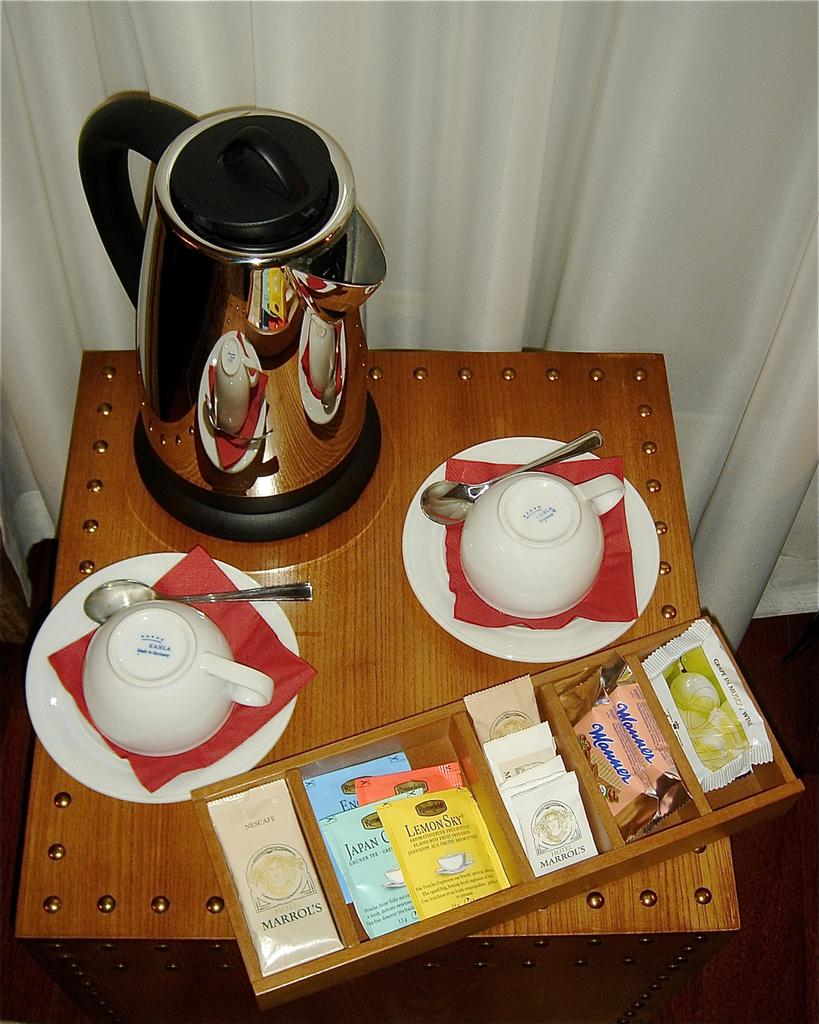What is the main object in the image? There is a kettle in the image. What other items are present in the image? There are cups and spoons on saucers, packets in a wooden box, blocks on a platform, and a curtain in the image. What might be used for serving or drinking in the image? Cups and spoons on saucers can be used for serving or drinking. What is the purpose of the wooden box in the image? The wooden box contains packets, which might be tea or other beverage ingredients. What type of shirt is hanging on the curtain in the image? There is no shirt present in the image, and the curtain is not being used to hang any clothing. 